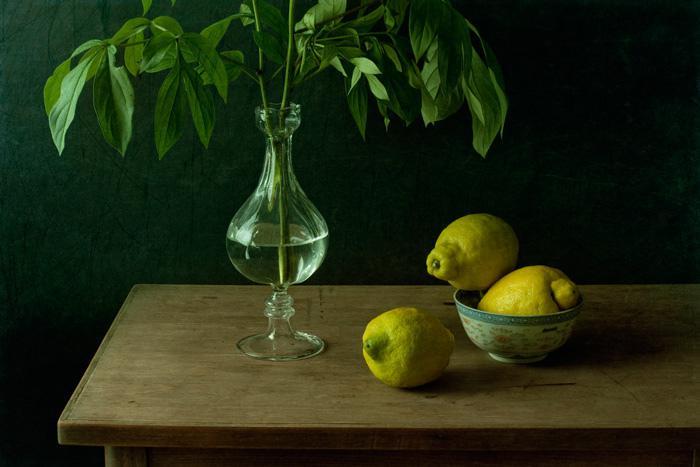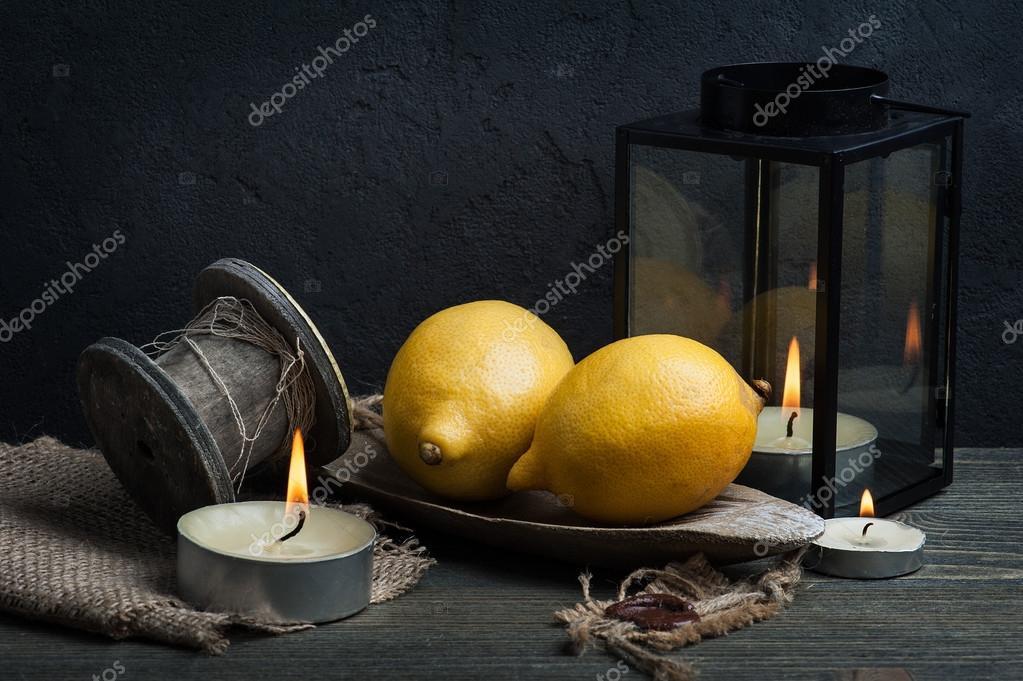The first image is the image on the left, the second image is the image on the right. Analyze the images presented: Is the assertion "There are three whole lemons lined up in a row in at least one of the images." valid? Answer yes or no. No. The first image is the image on the left, the second image is the image on the right. For the images shown, is this caption "Some lemons are in a bowl." true? Answer yes or no. Yes. 